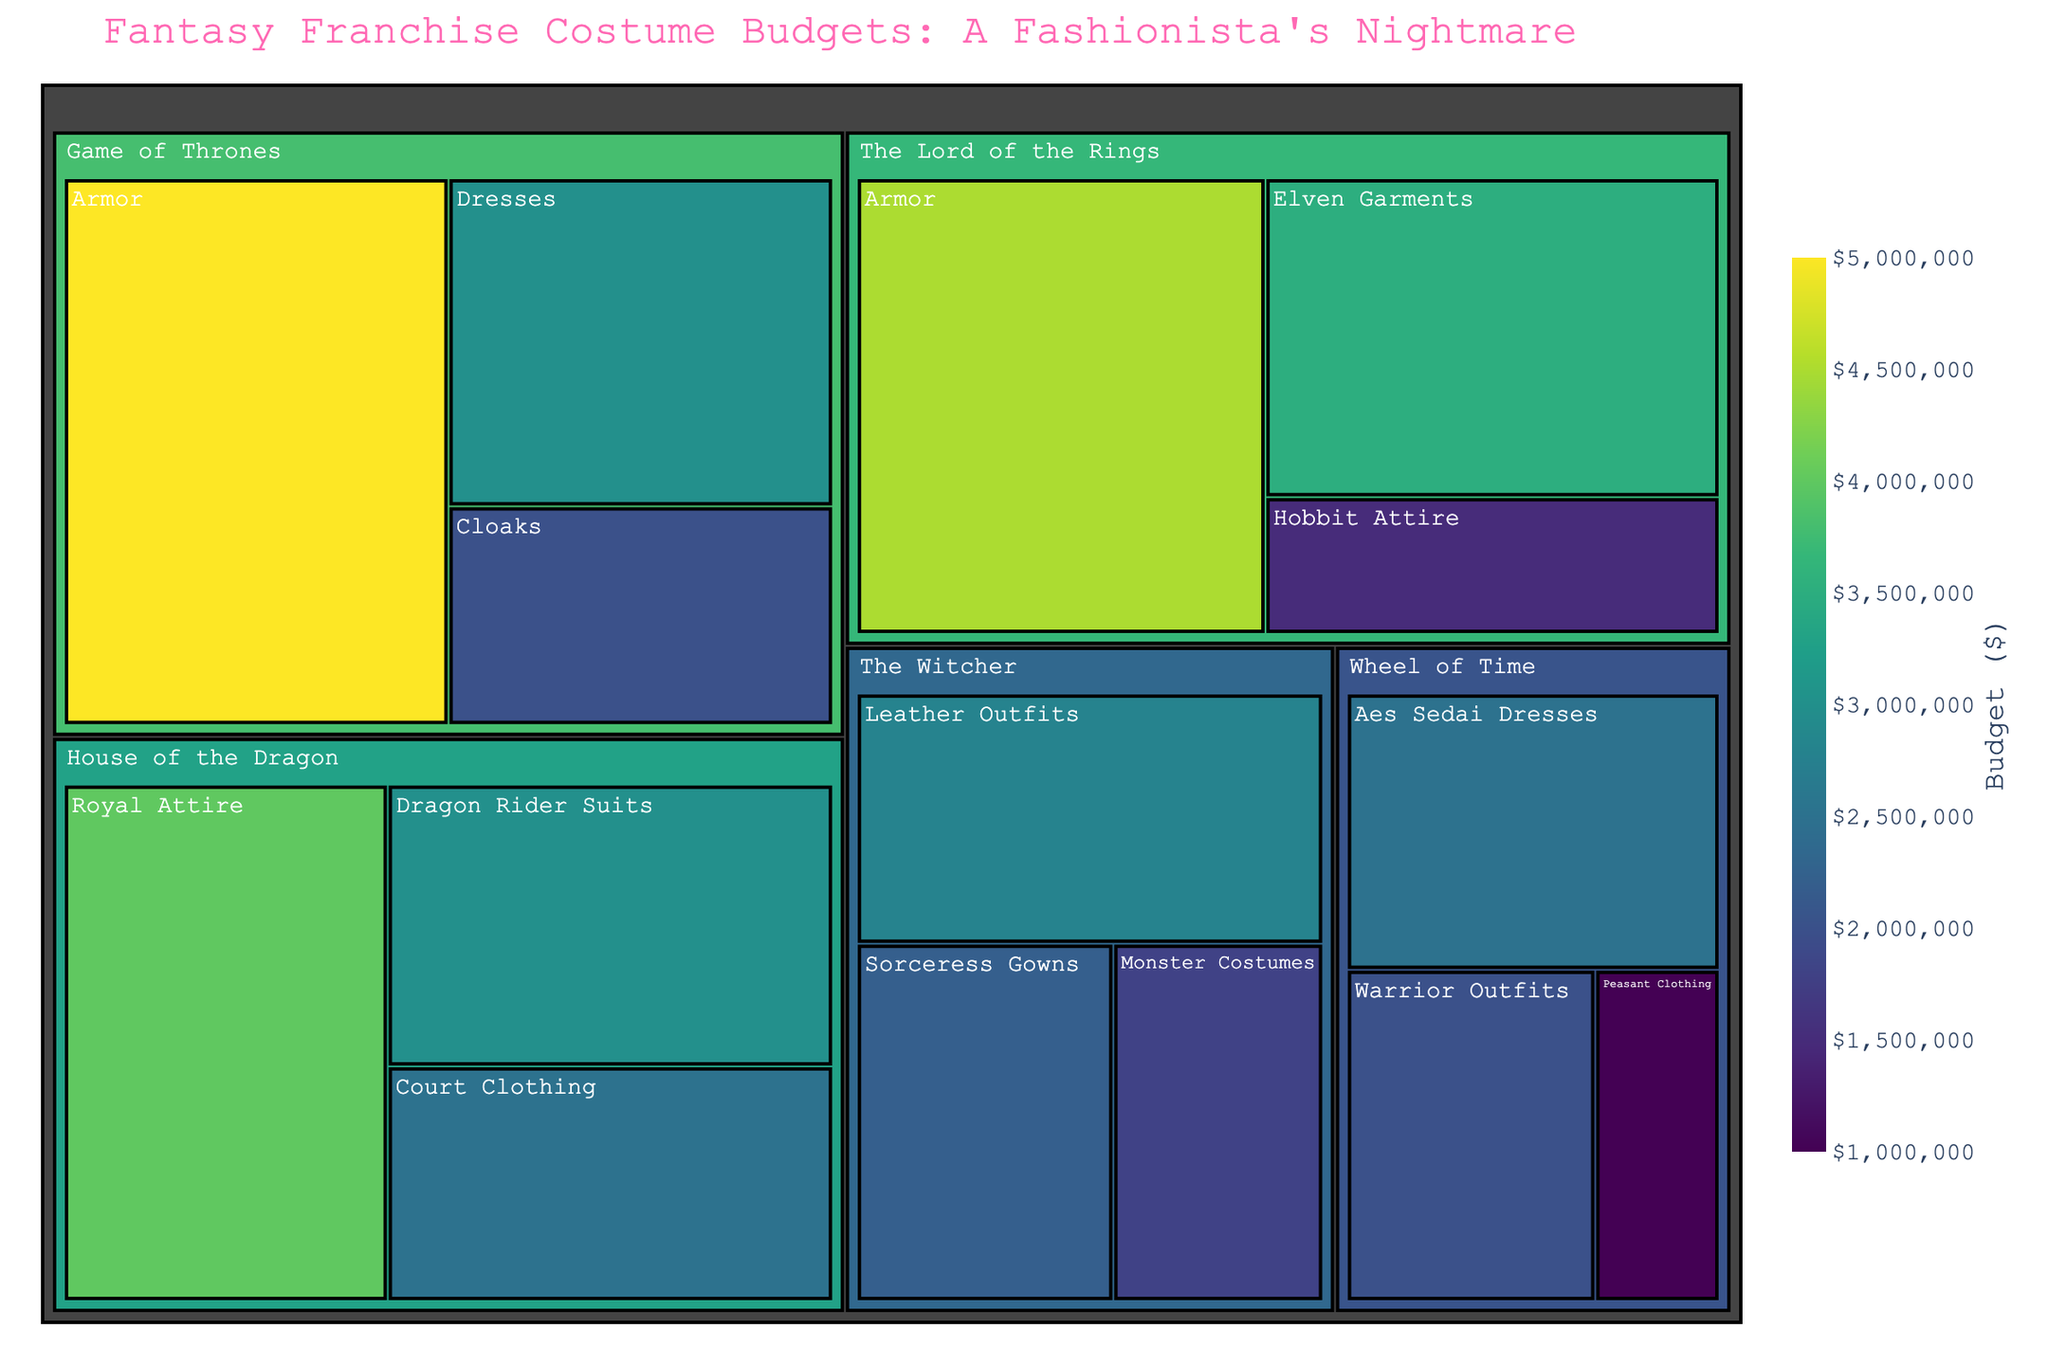What is the title of the treemap? The title is usually displayed at the top of the figure. Here, it is clearly written as "Fantasy Franchise Costume Budgets: A Fashionista's Nightmare".
Answer: Fantasy Franchise Costume Budgets: A Fashionista's Nightmare Which fantasy franchise has the highest budget for armor? By observing the different categories and their budgets, we can see that "Game of Thrones" has the highest budget for armor at $5,000,000.
Answer: Game of Thrones How many categories are there under "The Witcher"? Each leaf in the treemap represents a category. Under "The Witcher", we can count three categories: Leather Outfits, Sorceress Gowns, and Monster Costumes.
Answer: 3 What is the total costume budget for "Wheel of Time"? Summing up the budgets for the categories under "Wheel of Time" (Aes Sedai Dresses, Warrior Outfits, Peasant Clothing) gives us $2,500,000 + $2,000,000 + $1,000,000 = $5,500,000.
Answer: $5,500,000 Which category has the smallest budget and which franchise does it belong to? By identifying the smallest leaf in the treemap, we find "Peasant Clothing" under "Wheel of Time" with a budget of $1,000,000.
Answer: Peasant Clothing, Wheel of Time Between "House of the Dragon" and "The Lord of the Rings", which franchise has a higher total costume budget? Adding up the budgets for "House of the Dragon" (Royal Attire, Dragon Rider Suits, Court Clothing) gives us $4,000,000 + $3,000,000 + $2,500,000 = $9,500,000. Adding up the budgets for "The Lord of the Rings" (Armor, Elven Garments, Hobbit Attire) gives us $4,500,000 + $3,500,000 + $1,500,000 = $9,500,000. Both franchises have an equal total costume budget of $9,500,000.
Answer: Both have equal budgets What is the average budget of the categories under "Game of Thrones"? The budgets for the categories under "Game of Thrones" are $5,000,000, $3,000,000, and $2,000,000. Summing these gives $10,000,000, and dividing by 3 (the number of categories) gives an average budget of $3,333,333.33.
Answer: $3,333,333.33 Which franchise has the highest number of categories? By counting the categories under each franchise in the treemap, we find that "The Lord of the Rings" and "The Witcher" each have 3 categories, tying for the highest number.
Answer: The Lord of the Rings and The Witcher 